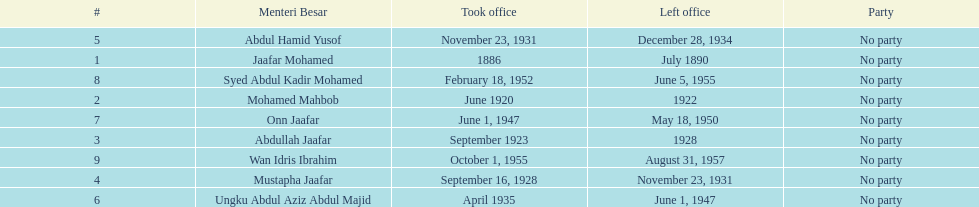Who are all of the menteri besars? Jaafar Mohamed, Mohamed Mahbob, Abdullah Jaafar, Mustapha Jaafar, Abdul Hamid Yusof, Ungku Abdul Aziz Abdul Majid, Onn Jaafar, Syed Abdul Kadir Mohamed, Wan Idris Ibrahim. When did each take office? 1886, June 1920, September 1923, September 16, 1928, November 23, 1931, April 1935, June 1, 1947, February 18, 1952, October 1, 1955. When did they leave? July 1890, 1922, 1928, November 23, 1931, December 28, 1934, June 1, 1947, May 18, 1950, June 5, 1955, August 31, 1957. And which spent the most time in office? Ungku Abdul Aziz Abdul Majid. 